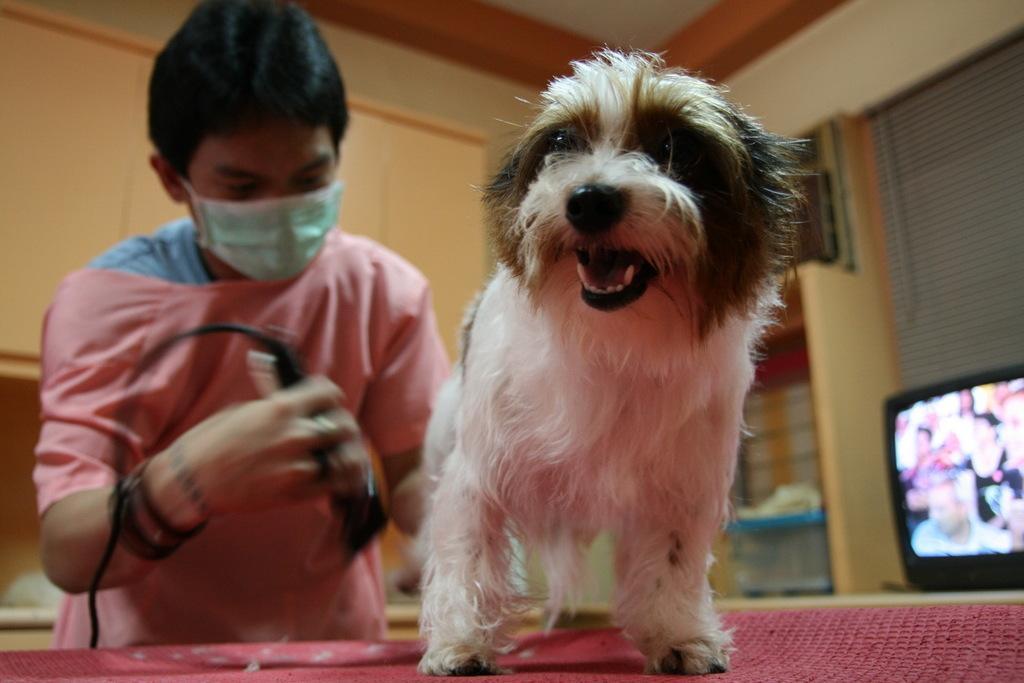Please provide a concise description of this image. In this image there is a dog on a table, behind the dog there is a person holding a trimmer in his hand, behind the dog there is a television. 